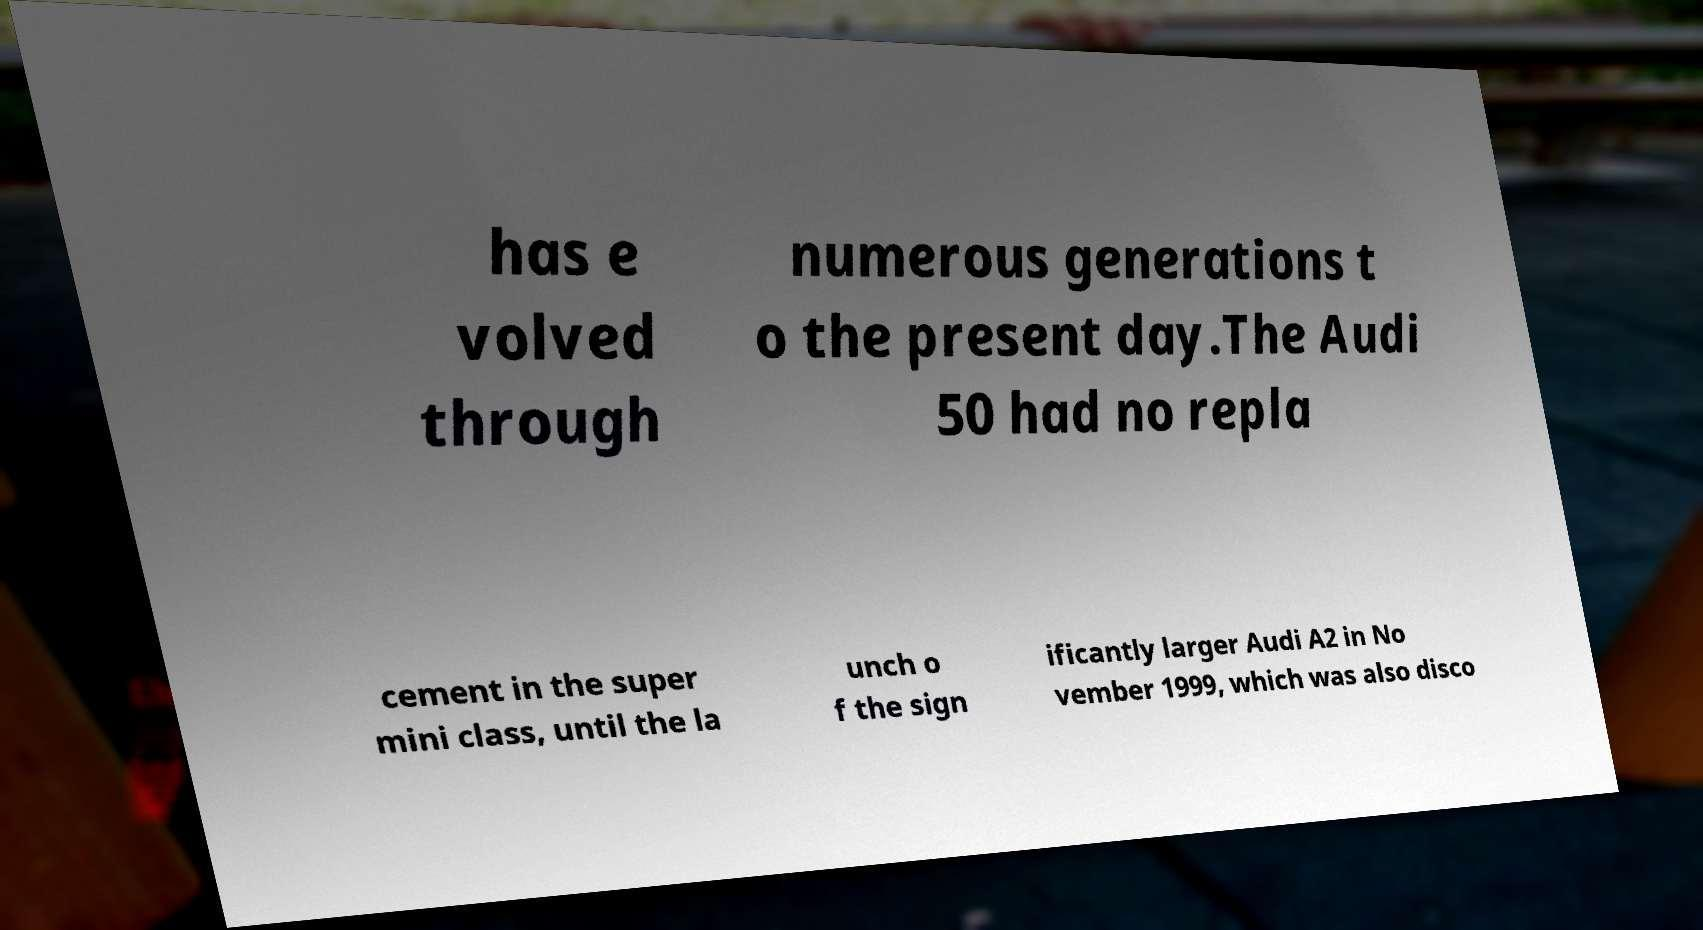There's text embedded in this image that I need extracted. Can you transcribe it verbatim? has e volved through numerous generations t o the present day.The Audi 50 had no repla cement in the super mini class, until the la unch o f the sign ificantly larger Audi A2 in No vember 1999, which was also disco 